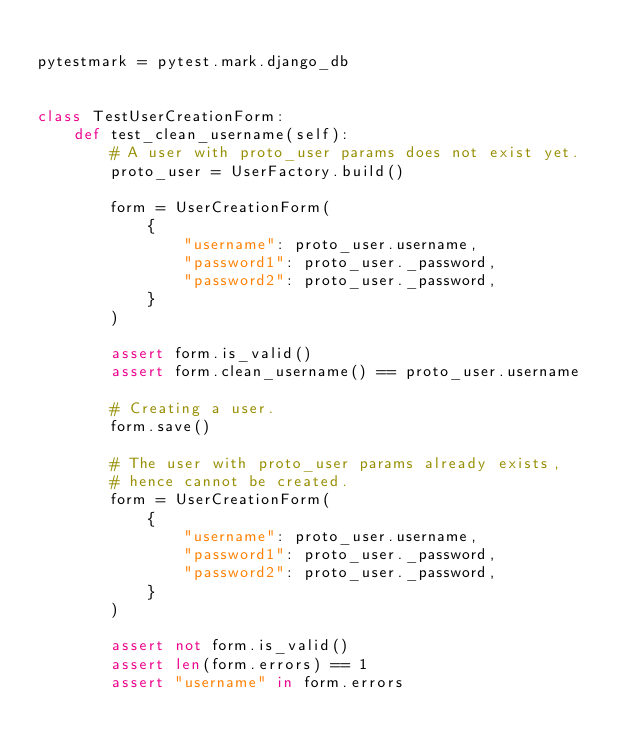<code> <loc_0><loc_0><loc_500><loc_500><_Python_>
pytestmark = pytest.mark.django_db


class TestUserCreationForm:
    def test_clean_username(self):
        # A user with proto_user params does not exist yet.
        proto_user = UserFactory.build()

        form = UserCreationForm(
            {
                "username": proto_user.username,
                "password1": proto_user._password,
                "password2": proto_user._password,
            }
        )

        assert form.is_valid()
        assert form.clean_username() == proto_user.username

        # Creating a user.
        form.save()

        # The user with proto_user params already exists,
        # hence cannot be created.
        form = UserCreationForm(
            {
                "username": proto_user.username,
                "password1": proto_user._password,
                "password2": proto_user._password,
            }
        )

        assert not form.is_valid()
        assert len(form.errors) == 1
        assert "username" in form.errors
</code> 